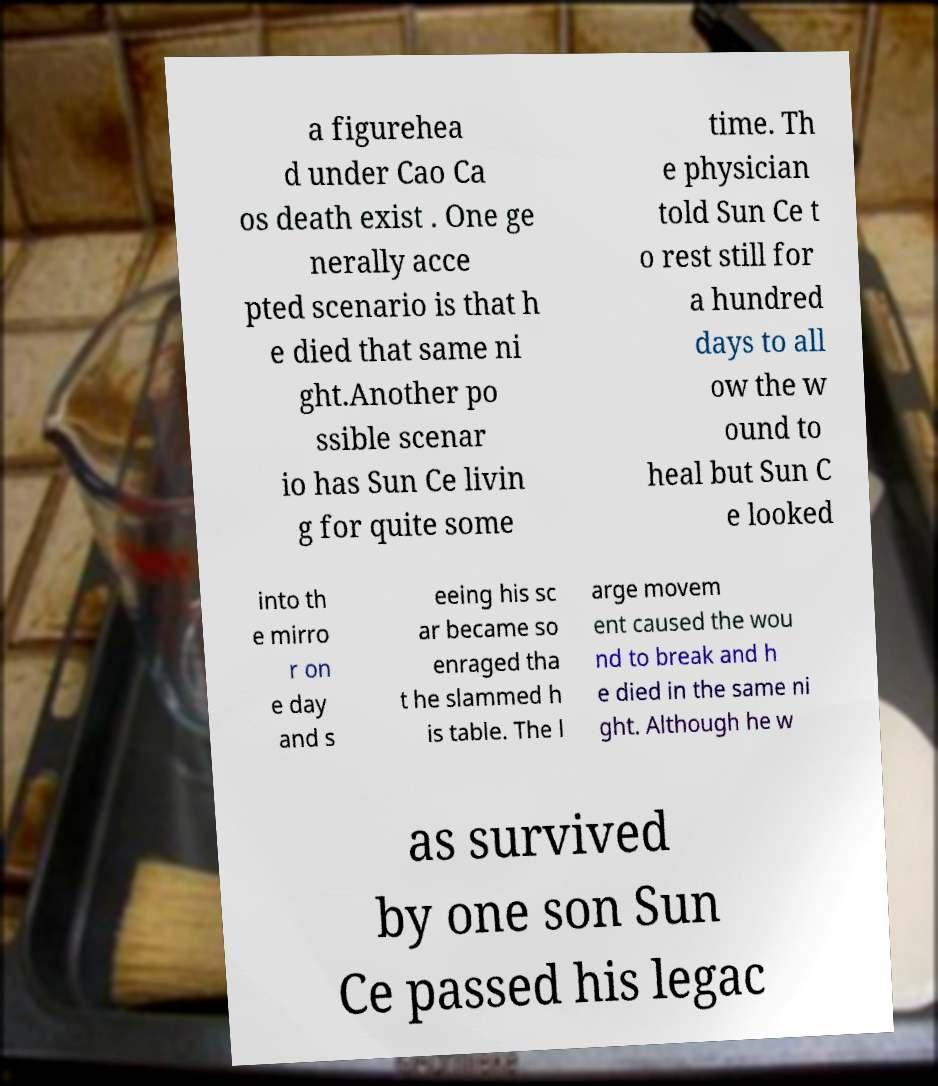I need the written content from this picture converted into text. Can you do that? a figurehea d under Cao Ca os death exist . One ge nerally acce pted scenario is that h e died that same ni ght.Another po ssible scenar io has Sun Ce livin g for quite some time. Th e physician told Sun Ce t o rest still for a hundred days to all ow the w ound to heal but Sun C e looked into th e mirro r on e day and s eeing his sc ar became so enraged tha t he slammed h is table. The l arge movem ent caused the wou nd to break and h e died in the same ni ght. Although he w as survived by one son Sun Ce passed his legac 